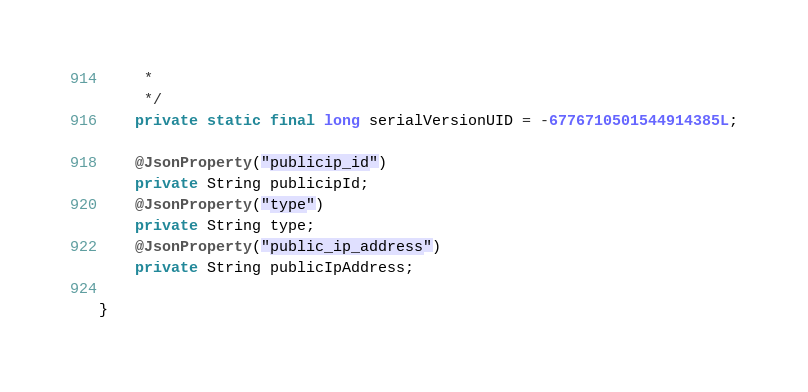<code> <loc_0><loc_0><loc_500><loc_500><_Java_>	 * 
	 */
	private static final long serialVersionUID = -6776710501544914385L;
	
	@JsonProperty("publicip_id")
	private String publicipId;
	@JsonProperty("type")
	private String type;
	@JsonProperty("public_ip_address")
	private String publicIpAddress;
	
}
</code> 